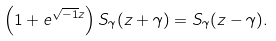Convert formula to latex. <formula><loc_0><loc_0><loc_500><loc_500>\left ( 1 + e ^ { \sqrt { - 1 } z } \right ) S _ { \gamma } ( z + \gamma ) = S _ { \gamma } ( z - \gamma ) .</formula> 